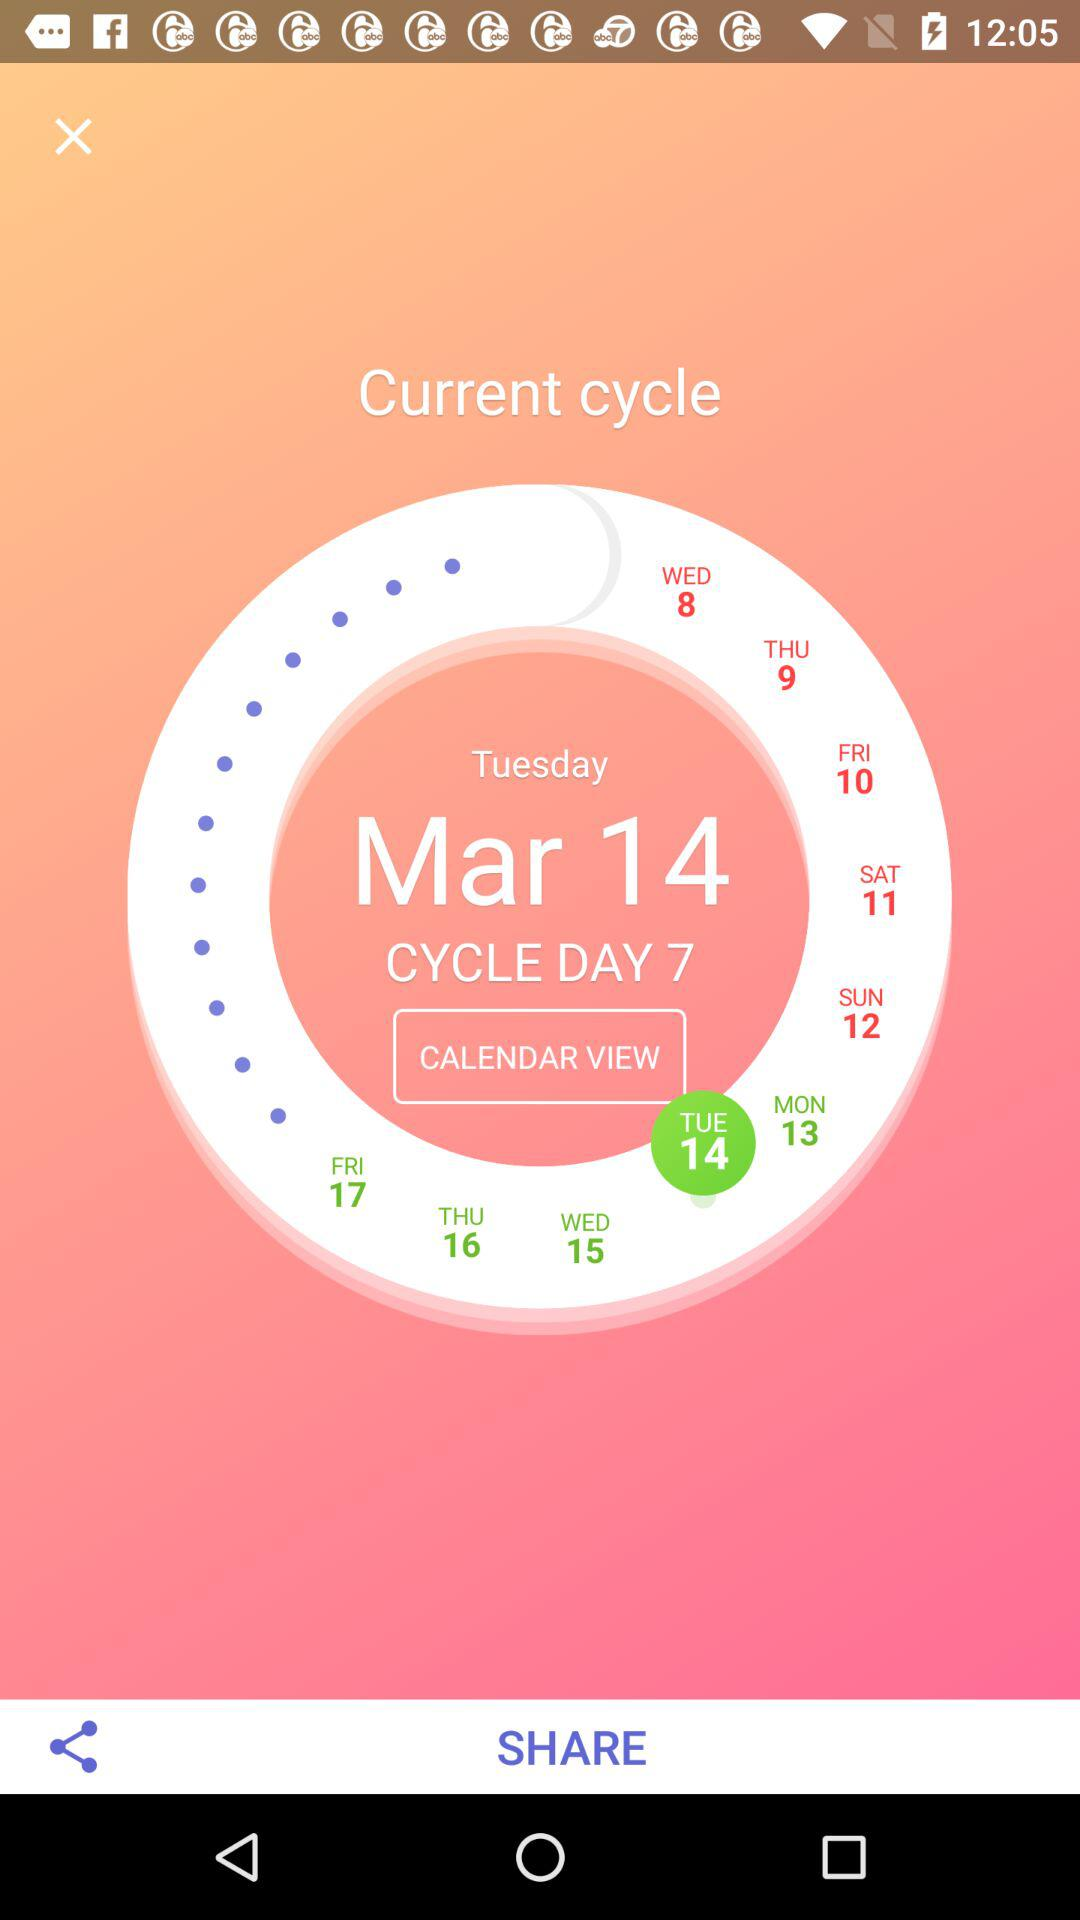What's the day of "Current Cycle Day"? The day is Tuesday. 